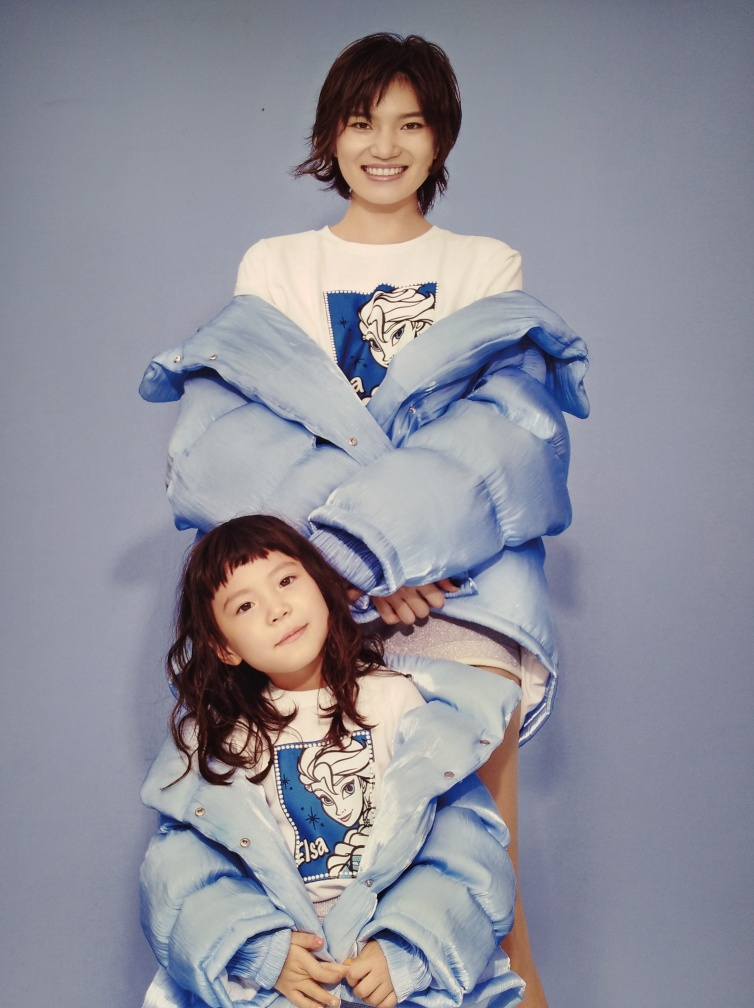Is the exposure of the image correct?
A. No
B. Yes
Answer with the option's letter from the given choices directly.
 B. 